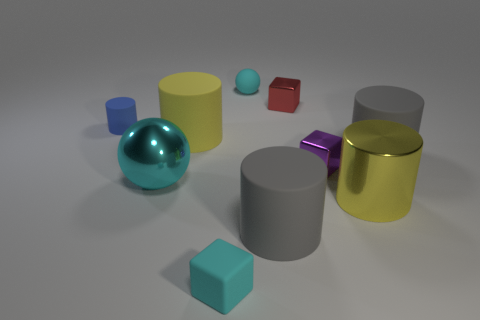There is a cyan sphere that is the same size as the metallic cylinder; what is it made of?
Your answer should be compact. Metal. What number of other objects are there of the same material as the tiny purple object?
Ensure brevity in your answer.  3. Are there the same number of big cyan metal balls on the right side of the tiny red metal block and tiny cyan matte spheres left of the purple object?
Your answer should be compact. No. How many blue objects are small rubber balls or rubber things?
Provide a short and direct response. 1. There is a small cylinder; is it the same color as the sphere that is in front of the tiny sphere?
Keep it short and to the point. No. What number of other things are the same color as the metallic cylinder?
Your answer should be very brief. 1. Is the number of small green shiny cylinders less than the number of tiny red things?
Offer a very short reply. Yes. There is a tiny metallic cube that is in front of the yellow cylinder left of the red metal object; what number of cubes are on the right side of it?
Ensure brevity in your answer.  0. There is a gray object that is on the left side of the tiny purple object; what is its size?
Provide a succinct answer. Large. Is the shape of the tiny cyan object in front of the small purple metal object the same as  the red metallic object?
Give a very brief answer. Yes. 